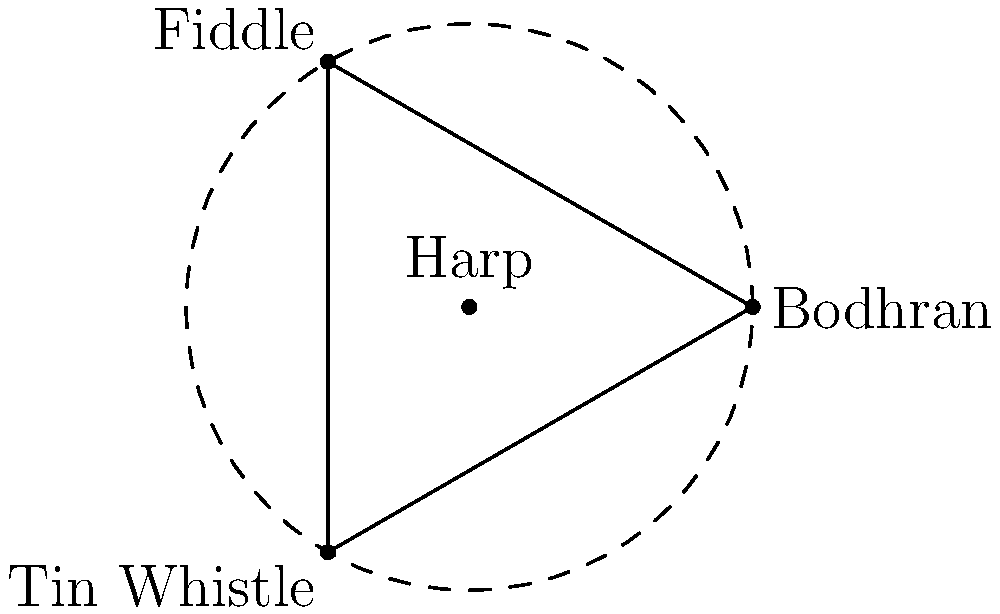In the arrangement of traditional Irish instruments shown above, the Bodhran, Fiddle, and Tin Whistle form the vertices of an equilateral triangle, while the Harp is at the center. If we consider rotations around the center and reflections across the lines connecting the center to each vertex, what is the order of the dihedral group representing all possible symmetries of this arrangement? To determine the order of the dihedral group for this arrangement, we need to follow these steps:

1. Identify the number of vertices (n) in the polygon formed by the instruments:
   The Bodhran, Fiddle, and Tin Whistle form an equilateral triangle, so n = 3.

2. Recall that for a regular n-gon, the dihedral group $D_n$ has order $2n$. This is because it includes:
   - n rotational symmetries (including the identity)
   - n reflectional symmetries

3. Calculate the order of the dihedral group:
   Order of $D_3 = 2 * 3 = 6$

The six elements of $D_3$ are:
- The identity transformation
- Rotations by 120° and 240°
- Three reflections across the lines connecting the center (Harp) to each vertex

Therefore, the dihedral group representing all possible symmetries of this arrangement of Irish instruments has an order of 6.
Answer: 6 